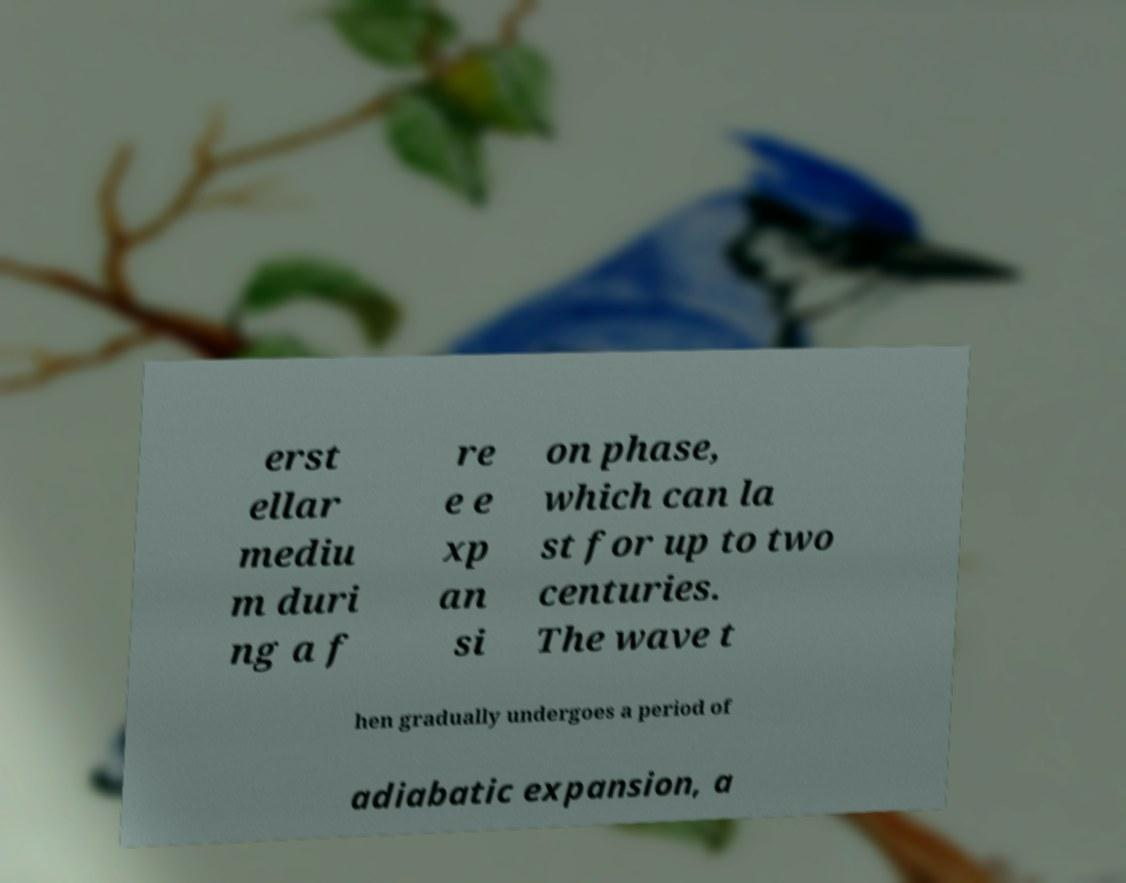For documentation purposes, I need the text within this image transcribed. Could you provide that? erst ellar mediu m duri ng a f re e e xp an si on phase, which can la st for up to two centuries. The wave t hen gradually undergoes a period of adiabatic expansion, a 